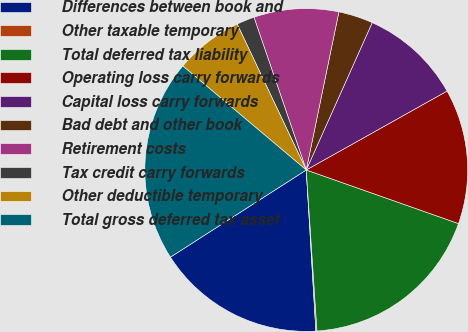Convert chart. <chart><loc_0><loc_0><loc_500><loc_500><pie_chart><fcel>Differences between book and<fcel>Other taxable temporary<fcel>Total deferred tax liability<fcel>Operating loss carry forwards<fcel>Capital loss carry forwards<fcel>Bad debt and other book<fcel>Retirement costs<fcel>Tax credit carry forwards<fcel>Other deductible temporary<fcel>Total gross deferred tax asset<nl><fcel>16.87%<fcel>0.11%<fcel>18.55%<fcel>13.52%<fcel>10.17%<fcel>3.46%<fcel>8.49%<fcel>1.79%<fcel>6.82%<fcel>20.22%<nl></chart> 